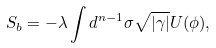<formula> <loc_0><loc_0><loc_500><loc_500>S _ { b } = - \lambda \int d ^ { n - 1 } \sigma \sqrt { | \gamma | } U ( \phi ) ,</formula> 